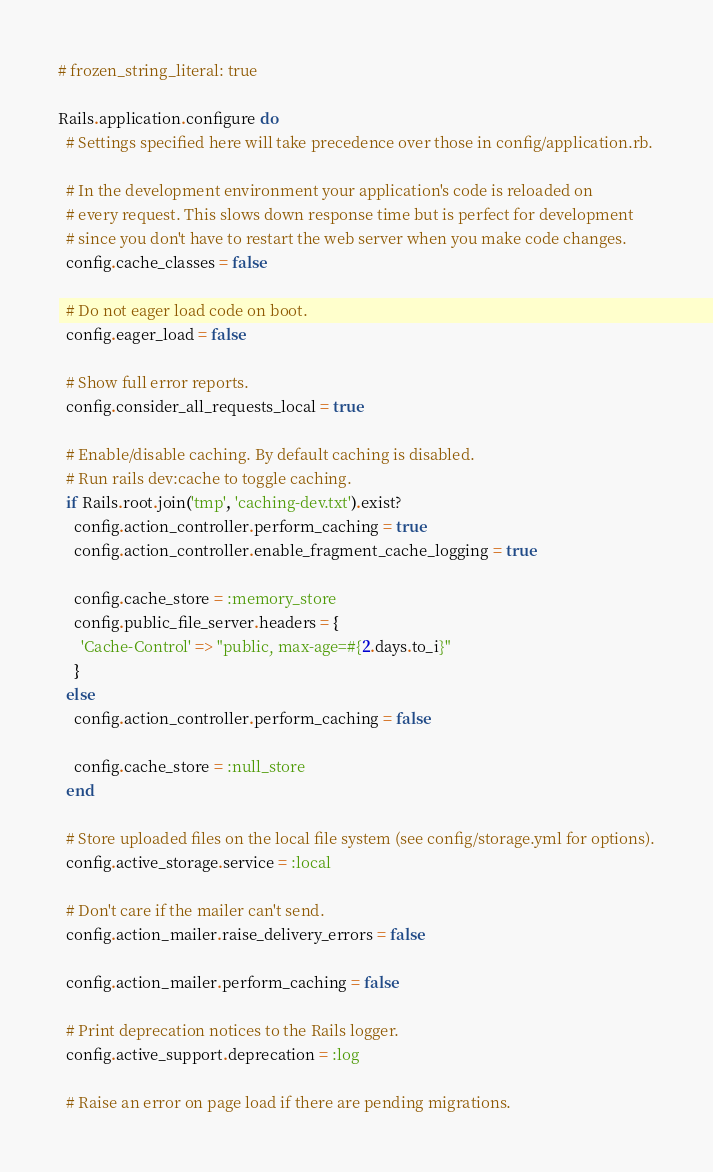<code> <loc_0><loc_0><loc_500><loc_500><_Ruby_># frozen_string_literal: true

Rails.application.configure do
  # Settings specified here will take precedence over those in config/application.rb.

  # In the development environment your application's code is reloaded on
  # every request. This slows down response time but is perfect for development
  # since you don't have to restart the web server when you make code changes.
  config.cache_classes = false

  # Do not eager load code on boot.
  config.eager_load = false

  # Show full error reports.
  config.consider_all_requests_local = true

  # Enable/disable caching. By default caching is disabled.
  # Run rails dev:cache to toggle caching.
  if Rails.root.join('tmp', 'caching-dev.txt').exist?
    config.action_controller.perform_caching = true
    config.action_controller.enable_fragment_cache_logging = true

    config.cache_store = :memory_store
    config.public_file_server.headers = {
      'Cache-Control' => "public, max-age=#{2.days.to_i}"
    }
  else
    config.action_controller.perform_caching = false

    config.cache_store = :null_store
  end

  # Store uploaded files on the local file system (see config/storage.yml for options).
  config.active_storage.service = :local

  # Don't care if the mailer can't send.
  config.action_mailer.raise_delivery_errors = false

  config.action_mailer.perform_caching = false

  # Print deprecation notices to the Rails logger.
  config.active_support.deprecation = :log

  # Raise an error on page load if there are pending migrations.</code> 